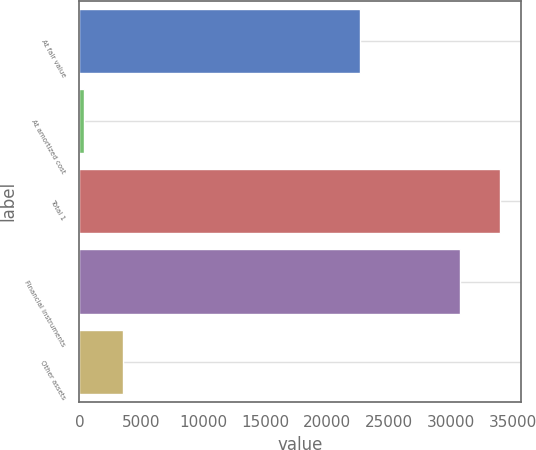<chart> <loc_0><loc_0><loc_500><loc_500><bar_chart><fcel>At fair value<fcel>At amortized cost<fcel>Total 1<fcel>Financial instruments<fcel>Other assets<nl><fcel>22685<fcel>360<fcel>33930<fcel>30765<fcel>3525<nl></chart> 